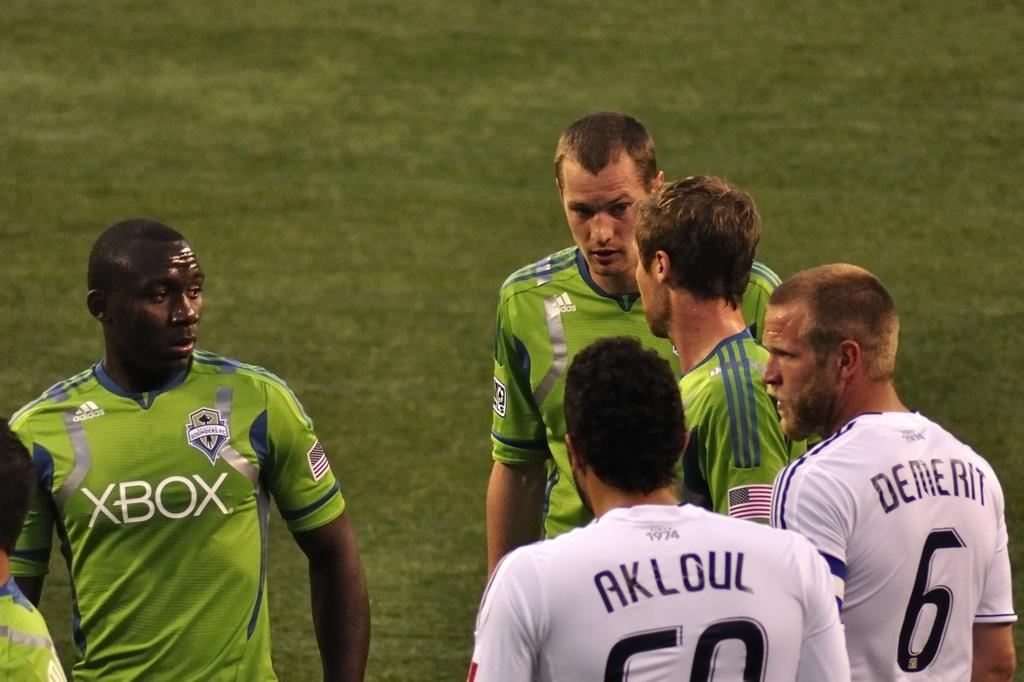Who is present in the image? There are people in the image. Where are the people located? The people are standing in a playground. What are the people wearing? The people are wearing green and white jerseys. What type of surface is visible in the image? There is grass on the floor in the image. How many pears can be seen in the image? There are no pears present in the image. What type of cats are visible in the image? There are no cats present in the image. 